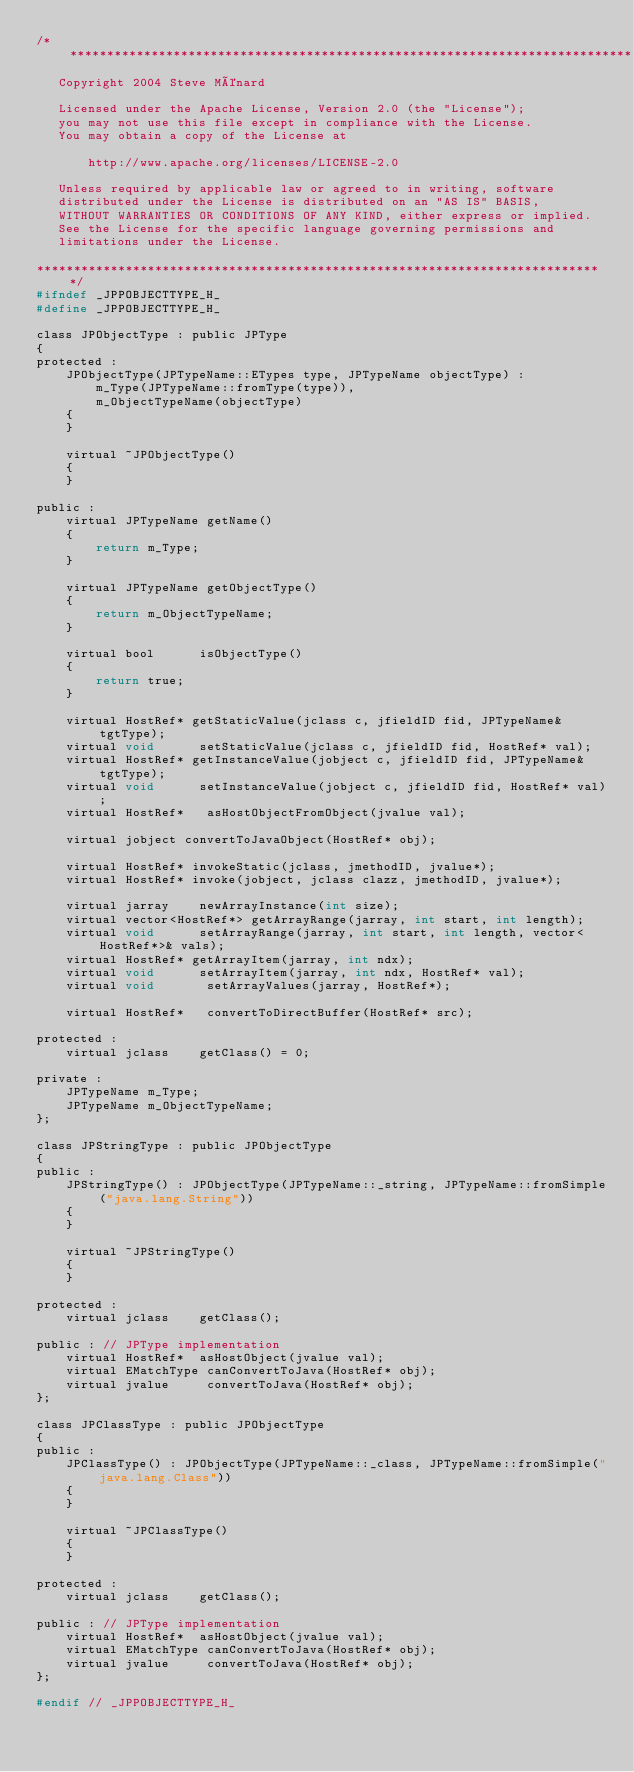<code> <loc_0><loc_0><loc_500><loc_500><_C_>/*****************************************************************************
   Copyright 2004 Steve Ménard

   Licensed under the Apache License, Version 2.0 (the "License");
   you may not use this file except in compliance with the License.
   You may obtain a copy of the License at

       http://www.apache.org/licenses/LICENSE-2.0

   Unless required by applicable law or agreed to in writing, software
   distributed under the License is distributed on an "AS IS" BASIS,
   WITHOUT WARRANTIES OR CONDITIONS OF ANY KIND, either express or implied.
   See the License for the specific language governing permissions and
   limitations under the License.
   
*****************************************************************************/   
#ifndef _JPPOBJECTTYPE_H_
#define _JPPOBJECTTYPE_H_

class JPObjectType : public JPType
{
protected :
	JPObjectType(JPTypeName::ETypes type, JPTypeName objectType) :
		m_Type(JPTypeName::fromType(type)),
		m_ObjectTypeName(objectType)
	{
	}
	
	virtual ~JPObjectType() 
	{
	}
	
public :
	virtual JPTypeName getName()
	{
		return m_Type;
	}
	
	virtual JPTypeName getObjectType()
	{
		return m_ObjectTypeName;
	}

	virtual bool      isObjectType() 
	{ 
		return true; 
	}

	virtual HostRef* getStaticValue(jclass c, jfieldID fid, JPTypeName& tgtType);
	virtual void      setStaticValue(jclass c, jfieldID fid, HostRef* val);
	virtual HostRef* getInstanceValue(jobject c, jfieldID fid, JPTypeName& tgtType);
	virtual void      setInstanceValue(jobject c, jfieldID fid, HostRef* val);
	virtual HostRef*   asHostObjectFromObject(jvalue val);

	virtual jobject convertToJavaObject(HostRef* obj);

	virtual HostRef* invokeStatic(jclass, jmethodID, jvalue*);
	virtual HostRef* invoke(jobject, jclass clazz, jmethodID, jvalue*);

	virtual jarray    newArrayInstance(int size);
	virtual vector<HostRef*> getArrayRange(jarray, int start, int length);
	virtual void      setArrayRange(jarray, int start, int length, vector<HostRef*>& vals);
	virtual HostRef* getArrayItem(jarray, int ndx);
	virtual void      setArrayItem(jarray, int ndx, HostRef* val);
	virtual void       setArrayValues(jarray, HostRef*);
	
	virtual HostRef*   convertToDirectBuffer(HostRef* src);

protected :
	virtual jclass    getClass() = 0;	
	
private :
	JPTypeName m_Type;
	JPTypeName m_ObjectTypeName;
};

class JPStringType : public JPObjectType
{
public :
	JPStringType() : JPObjectType(JPTypeName::_string, JPTypeName::fromSimple("java.lang.String"))
	{
	}
	
	virtual ~JPStringType()
	{
	}

protected :
	virtual jclass    getClass();	

public : // JPType implementation	
	virtual HostRef*  asHostObject(jvalue val);
	virtual EMatchType canConvertToJava(HostRef* obj);
	virtual jvalue     convertToJava(HostRef* obj);
};

class JPClassType : public JPObjectType
{
public :
	JPClassType() : JPObjectType(JPTypeName::_class, JPTypeName::fromSimple("java.lang.Class"))
	{
	}
	
	virtual ~JPClassType()
	{
	}

protected :
	virtual jclass    getClass();	

public : // JPType implementation
	virtual HostRef*  asHostObject(jvalue val);
	virtual EMatchType canConvertToJava(HostRef* obj);
	virtual jvalue     convertToJava(HostRef* obj);
};

#endif // _JPPOBJECTTYPE_H_
</code> 